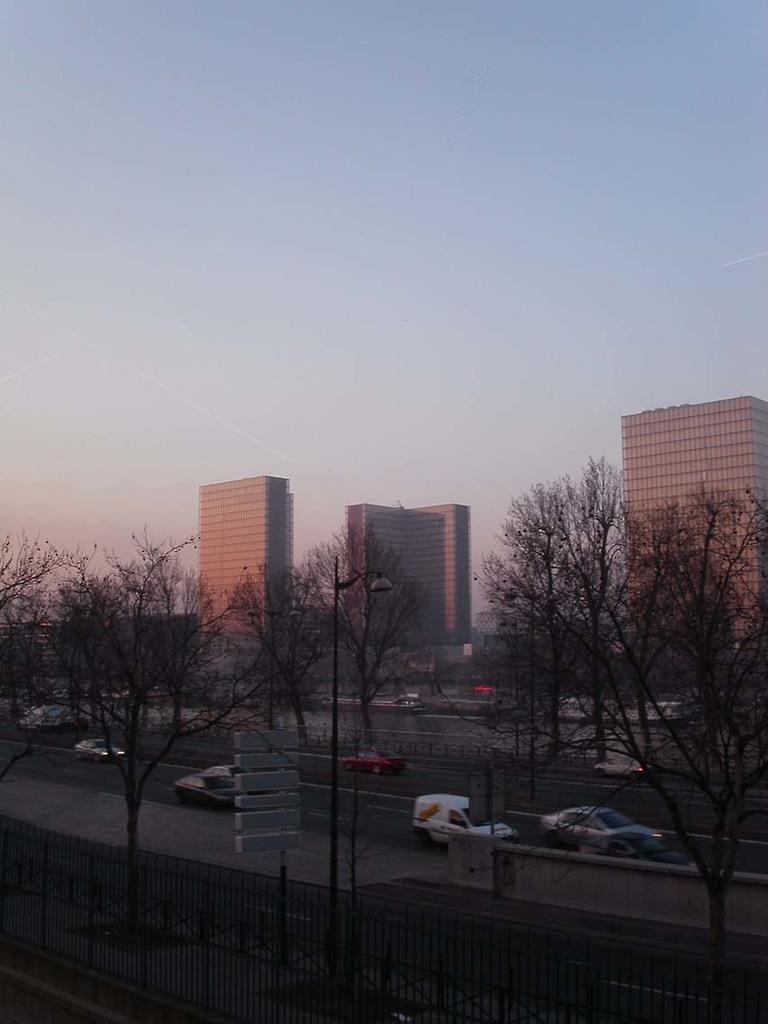Please provide a concise description of this image. In this image there are buildings, trees, moving vehicles on the road, railing and sign boards. In the background there is the sky. 